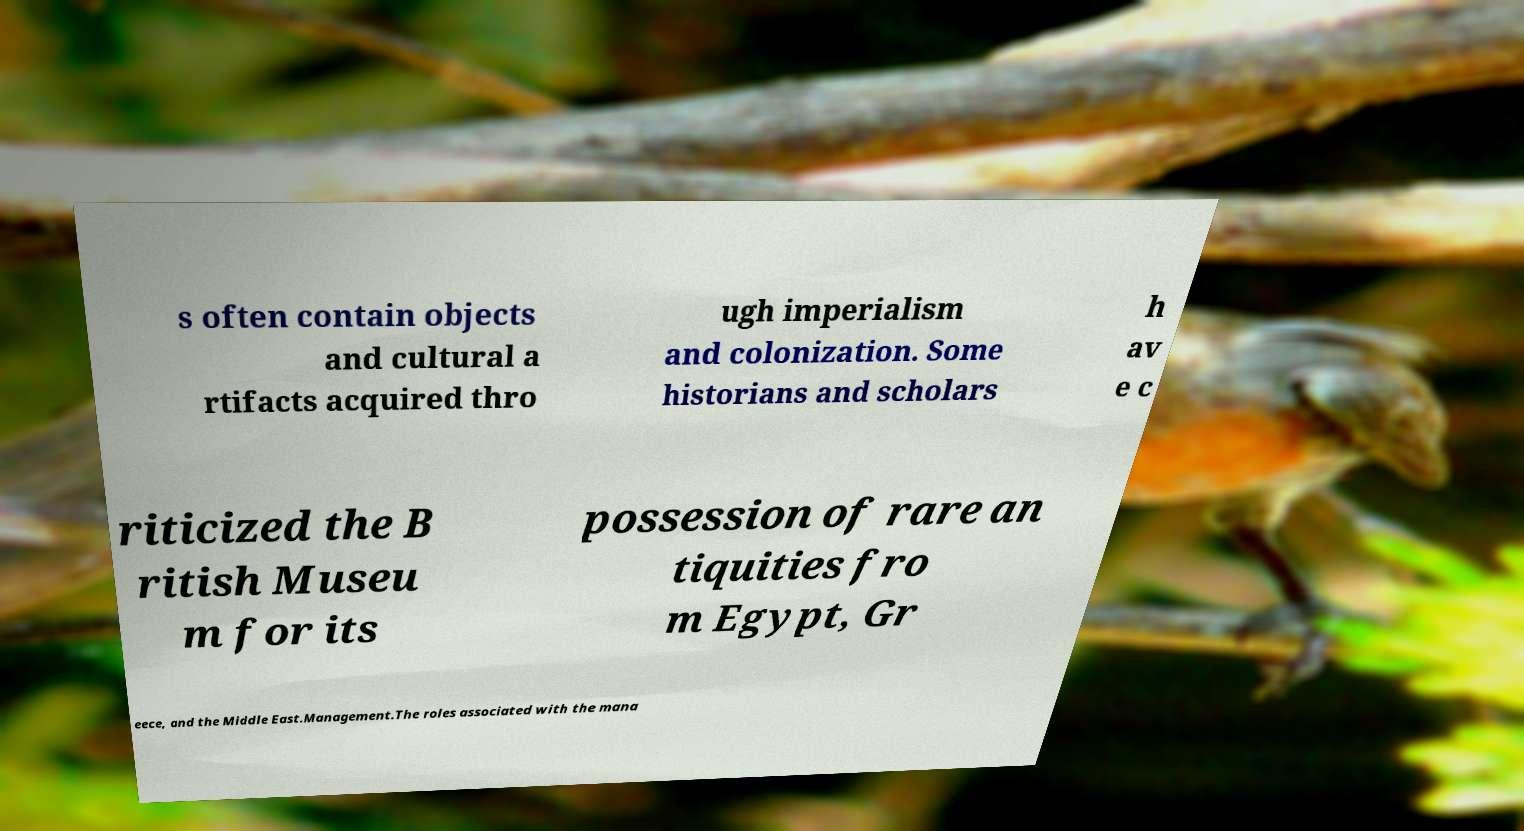Could you extract and type out the text from this image? s often contain objects and cultural a rtifacts acquired thro ugh imperialism and colonization. Some historians and scholars h av e c riticized the B ritish Museu m for its possession of rare an tiquities fro m Egypt, Gr eece, and the Middle East.Management.The roles associated with the mana 